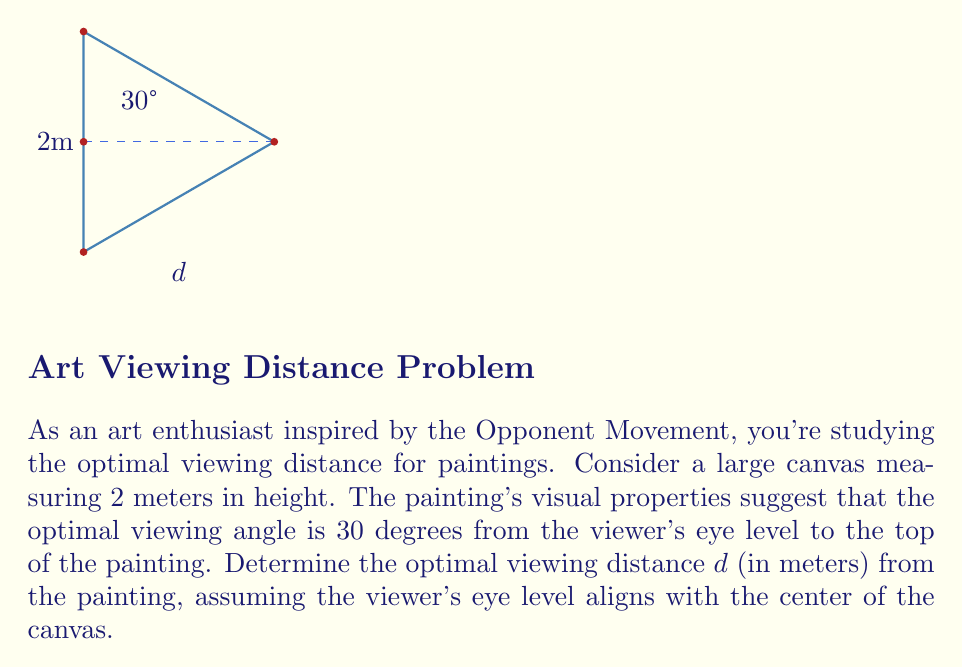Give your solution to this math problem. Let's approach this step-by-step using trigonometry and the given information:

1) We know the height of the painting is 2 meters, and the viewer's eye level aligns with the center. This means the distance from the eye level to the top of the painting is 1 meter.

2) We can create a right triangle where:
   - The vertical side is 1 meter (half the height of the painting)
   - The hypotenuse is the line from the viewer's eye to the top of the painting
   - The angle between these two lines is 30°

3) In this right triangle, we can use the tangent function:

   $$\tan(30°) = \frac{\text{opposite}}{\text{adjacent}} = \frac{1}{d}$$

4) We know that $\tan(30°) = \frac{1}{\sqrt{3}}$, so we can set up the equation:

   $$\frac{1}{\sqrt{3}} = \frac{1}{d}$$

5) Solving for $d$:

   $$d = \sqrt{3}$$

6) Therefore, the optimal viewing distance is $\sqrt{3}$ meters.

7) To get a decimal approximation:

   $$d \approx 1.73 \text{ meters}$$
Answer: $d = \sqrt{3} \approx 1.73 \text{ meters}$ 